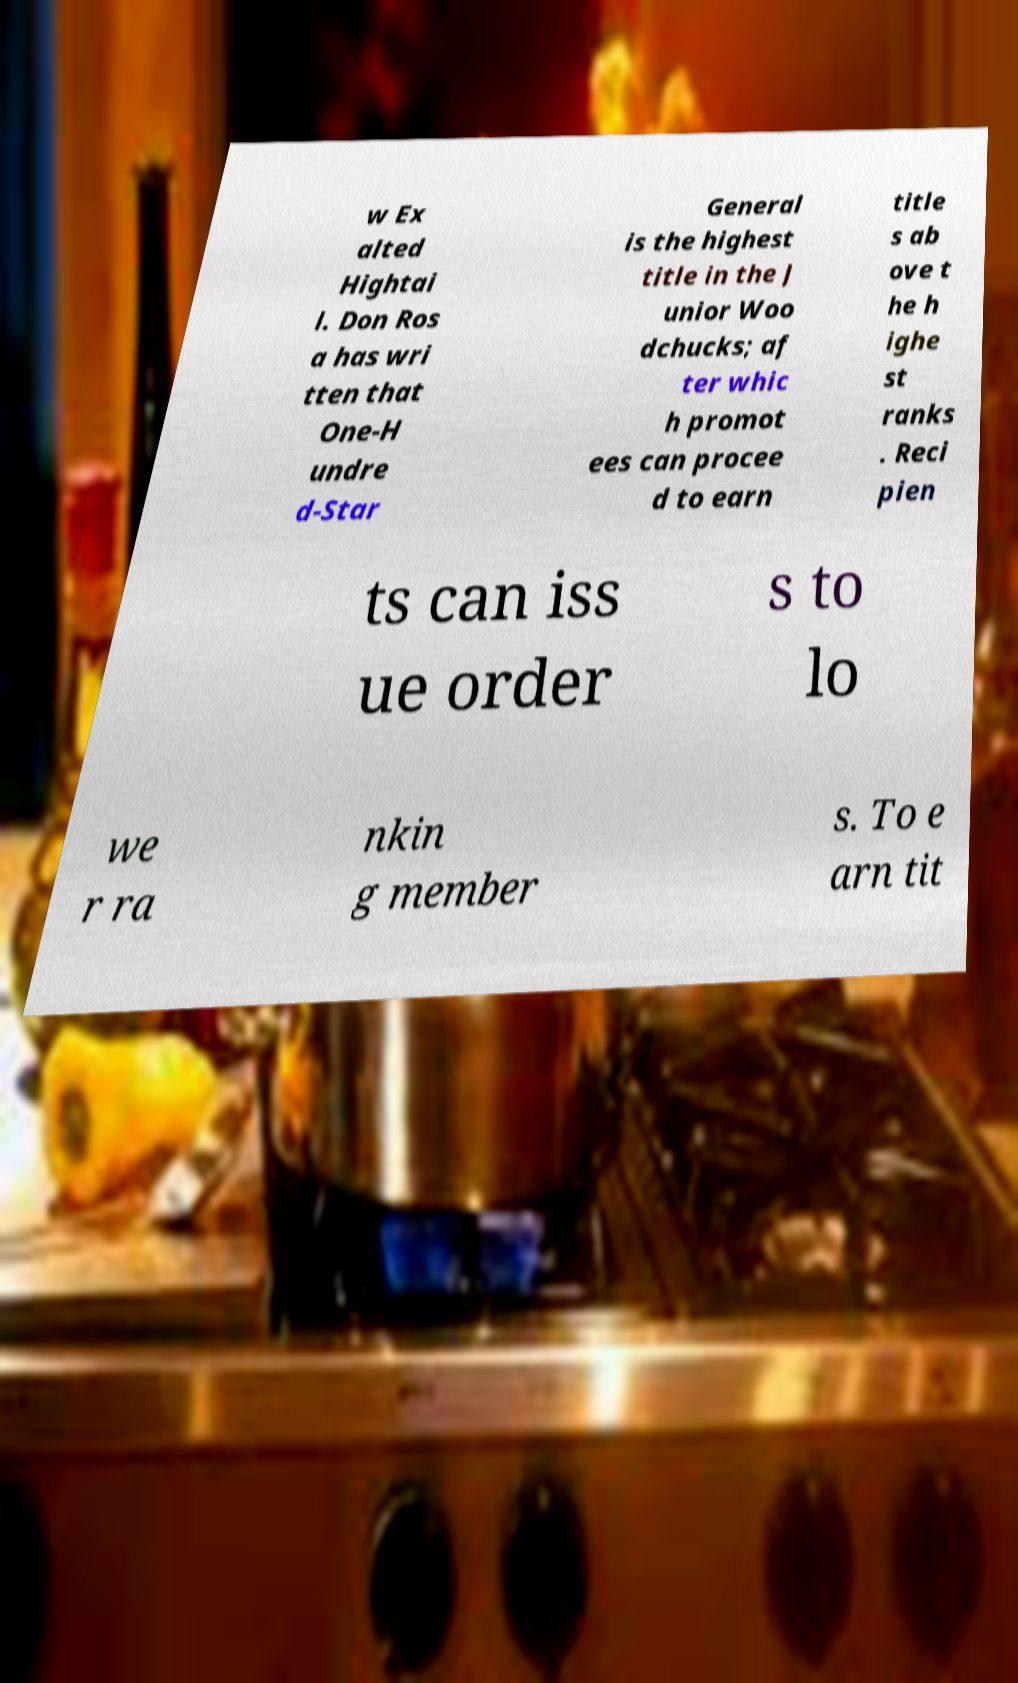Could you assist in decoding the text presented in this image and type it out clearly? w Ex alted Hightai l. Don Ros a has wri tten that One-H undre d-Star General is the highest title in the J unior Woo dchucks; af ter whic h promot ees can procee d to earn title s ab ove t he h ighe st ranks . Reci pien ts can iss ue order s to lo we r ra nkin g member s. To e arn tit 